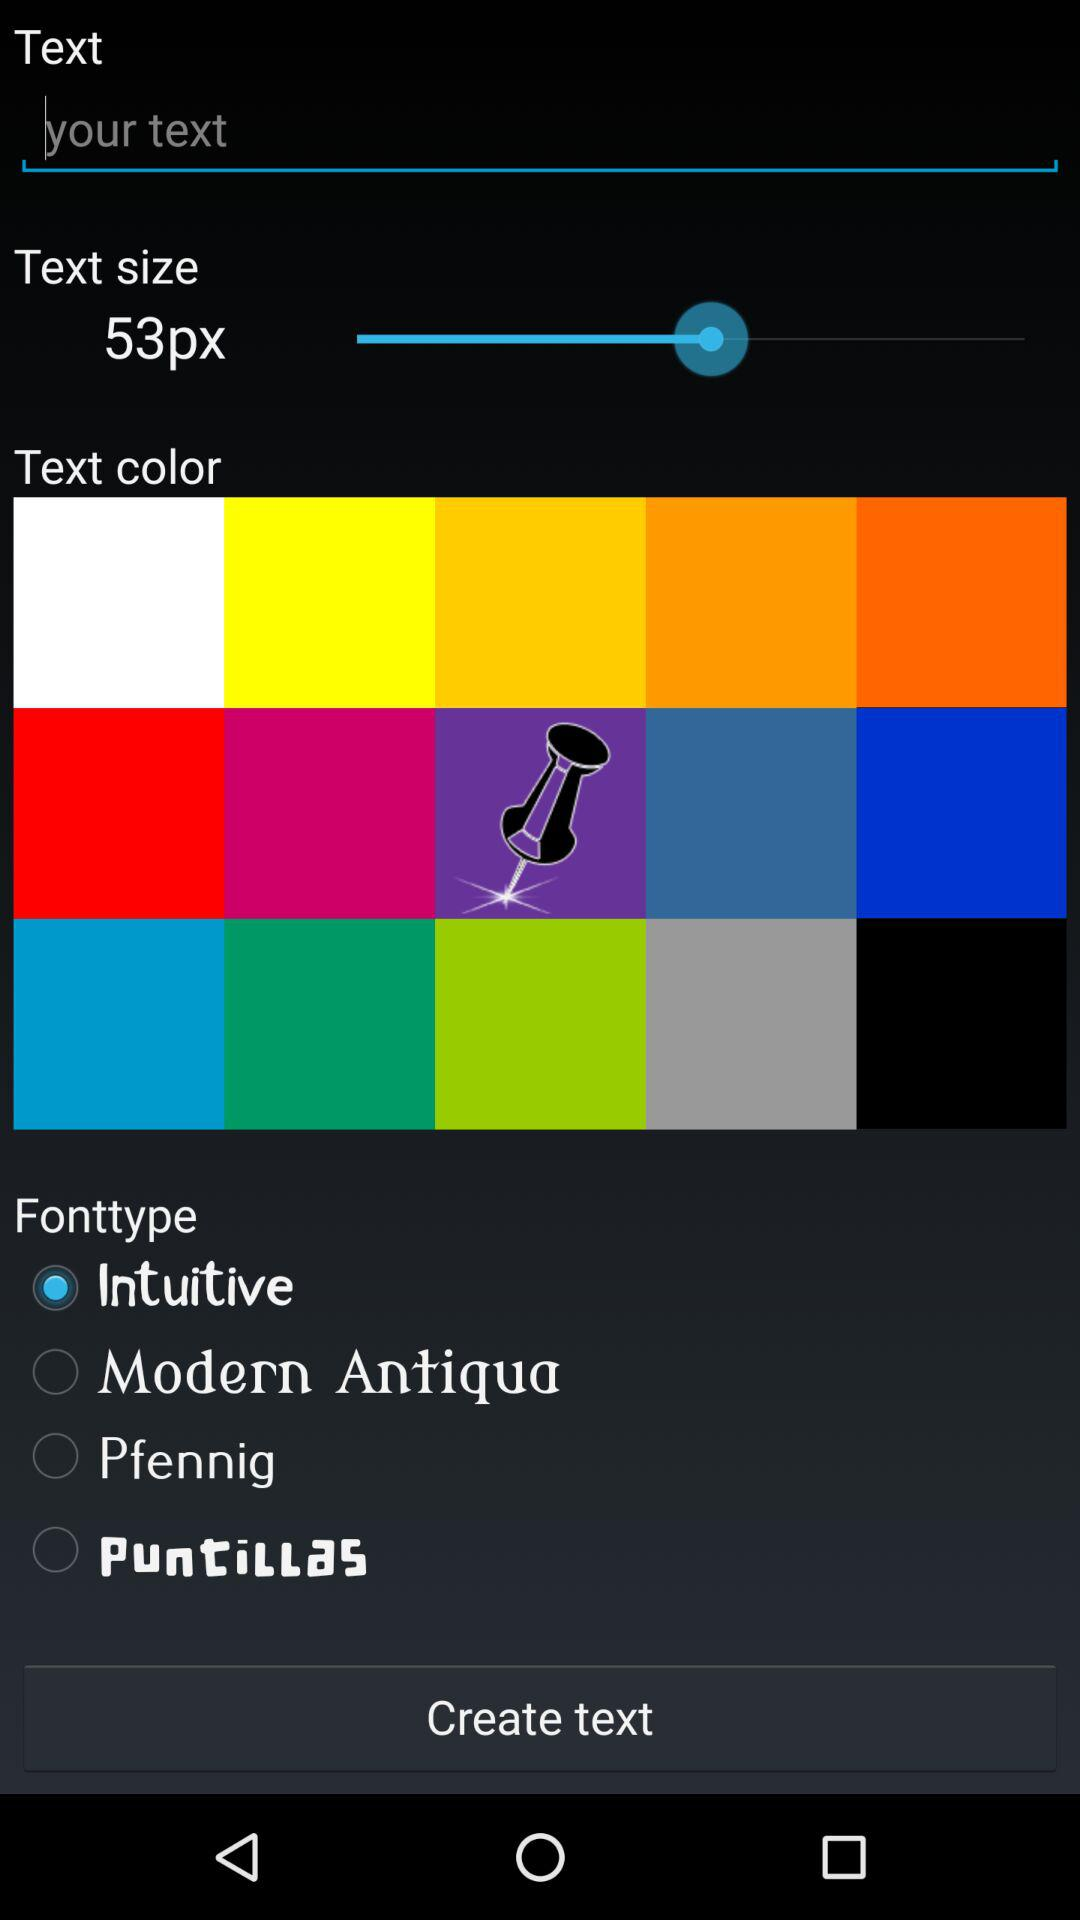What is the text size? The text size is 53 px. 